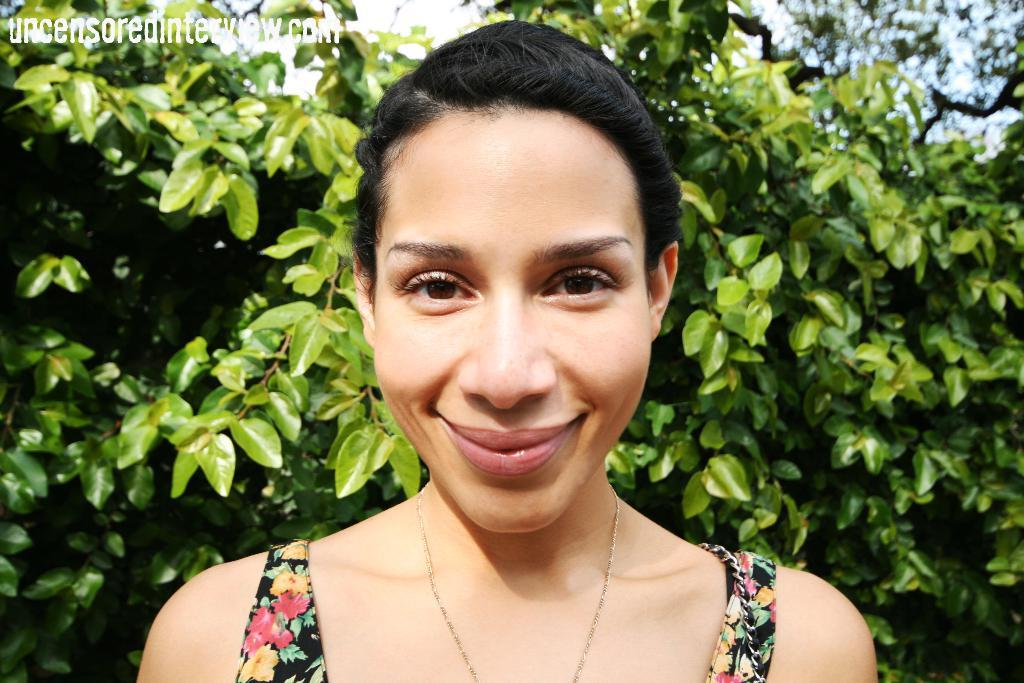Who is the main subject in the image? There is a woman in the middle of the image. What is the woman doing in the image? The woman is smiling. What can be seen in the top left corner of the image? There is a watermark on the top left of the image. What type of natural scenery is visible in the background of the image? There are trees and clouds in the blue sky in the background of the image. How much eggnog is being consumed by the woman in the image? There is no eggnog present in the image, so it cannot be determined how much is being consumed. 